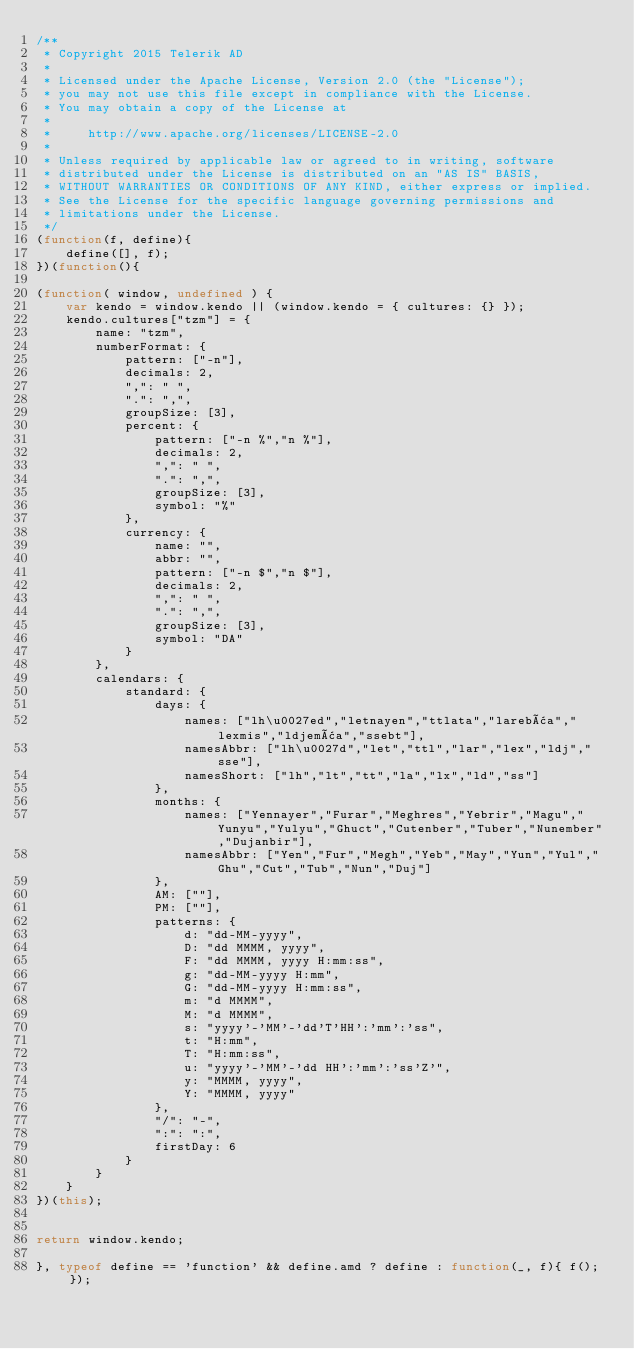Convert code to text. <code><loc_0><loc_0><loc_500><loc_500><_JavaScript_>/**
 * Copyright 2015 Telerik AD
 *
 * Licensed under the Apache License, Version 2.0 (the "License");
 * you may not use this file except in compliance with the License.
 * You may obtain a copy of the License at
 *
 *     http://www.apache.org/licenses/LICENSE-2.0
 *
 * Unless required by applicable law or agreed to in writing, software
 * distributed under the License is distributed on an "AS IS" BASIS,
 * WITHOUT WARRANTIES OR CONDITIONS OF ANY KIND, either express or implied.
 * See the License for the specific language governing permissions and
 * limitations under the License.
 */
(function(f, define){
    define([], f);
})(function(){

(function( window, undefined ) {
    var kendo = window.kendo || (window.kendo = { cultures: {} });
    kendo.cultures["tzm"] = {
        name: "tzm",
        numberFormat: {
            pattern: ["-n"],
            decimals: 2,
            ",": " ",
            ".": ",",
            groupSize: [3],
            percent: {
                pattern: ["-n %","n %"],
                decimals: 2,
                ",": " ",
                ".": ",",
                groupSize: [3],
                symbol: "%"
            },
            currency: {
                name: "",
                abbr: "",
                pattern: ["-n $","n $"],
                decimals: 2,
                ",": " ",
                ".": ",",
                groupSize: [3],
                symbol: "DA"
            }
        },
        calendars: {
            standard: {
                days: {
                    names: ["lh\u0027ed","letnayen","ttlata","larebâa","lexmis","ldjemâa","ssebt"],
                    namesAbbr: ["lh\u0027d","let","ttl","lar","lex","ldj","sse"],
                    namesShort: ["lh","lt","tt","la","lx","ld","ss"]
                },
                months: {
                    names: ["Yennayer","Furar","Meghres","Yebrir","Magu","Yunyu","Yulyu","Ghuct","Cutenber","Tuber","Nunember","Dujanbir"],
                    namesAbbr: ["Yen","Fur","Megh","Yeb","May","Yun","Yul","Ghu","Cut","Tub","Nun","Duj"]
                },
                AM: [""],
                PM: [""],
                patterns: {
                    d: "dd-MM-yyyy",
                    D: "dd MMMM, yyyy",
                    F: "dd MMMM, yyyy H:mm:ss",
                    g: "dd-MM-yyyy H:mm",
                    G: "dd-MM-yyyy H:mm:ss",
                    m: "d MMMM",
                    M: "d MMMM",
                    s: "yyyy'-'MM'-'dd'T'HH':'mm':'ss",
                    t: "H:mm",
                    T: "H:mm:ss",
                    u: "yyyy'-'MM'-'dd HH':'mm':'ss'Z'",
                    y: "MMMM, yyyy",
                    Y: "MMMM, yyyy"
                },
                "/": "-",
                ":": ":",
                firstDay: 6
            }
        }
    }
})(this);


return window.kendo;

}, typeof define == 'function' && define.amd ? define : function(_, f){ f(); });</code> 